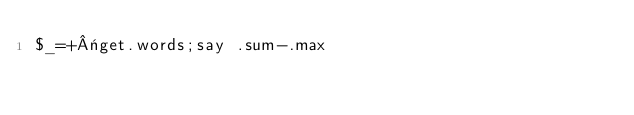<code> <loc_0><loc_0><loc_500><loc_500><_Perl_>$_=+«get.words;say .sum-.max</code> 